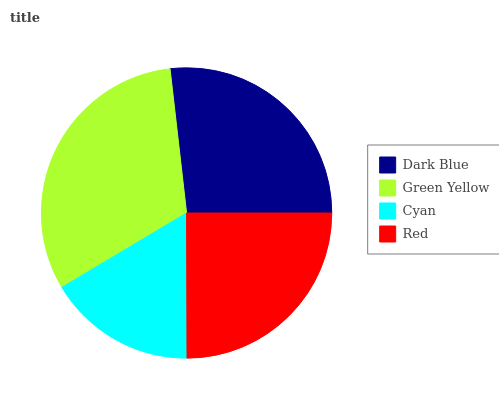Is Cyan the minimum?
Answer yes or no. Yes. Is Green Yellow the maximum?
Answer yes or no. Yes. Is Green Yellow the minimum?
Answer yes or no. No. Is Cyan the maximum?
Answer yes or no. No. Is Green Yellow greater than Cyan?
Answer yes or no. Yes. Is Cyan less than Green Yellow?
Answer yes or no. Yes. Is Cyan greater than Green Yellow?
Answer yes or no. No. Is Green Yellow less than Cyan?
Answer yes or no. No. Is Dark Blue the high median?
Answer yes or no. Yes. Is Red the low median?
Answer yes or no. Yes. Is Green Yellow the high median?
Answer yes or no. No. Is Green Yellow the low median?
Answer yes or no. No. 